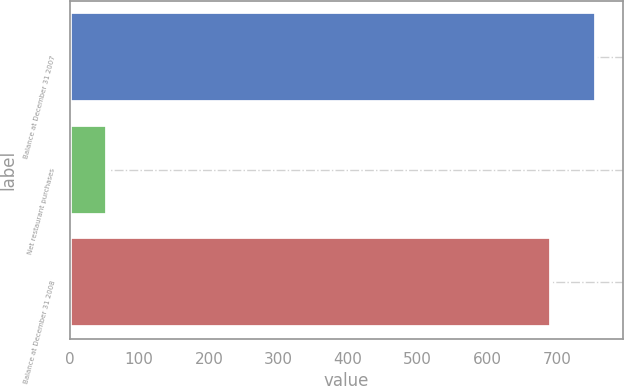Convert chart to OTSL. <chart><loc_0><loc_0><loc_500><loc_500><bar_chart><fcel>Balance at December 31 2007<fcel>Net restaurant purchases<fcel>Balance at December 31 2008<nl><fcel>756.7<fcel>53.2<fcel>692<nl></chart> 